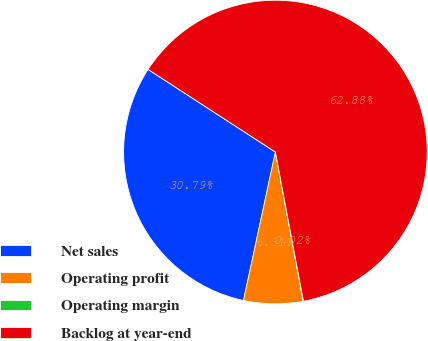Convert chart. <chart><loc_0><loc_0><loc_500><loc_500><pie_chart><fcel>Net sales<fcel>Operating profit<fcel>Operating margin<fcel>Backlog at year-end<nl><fcel>30.79%<fcel>6.31%<fcel>0.02%<fcel>62.88%<nl></chart> 